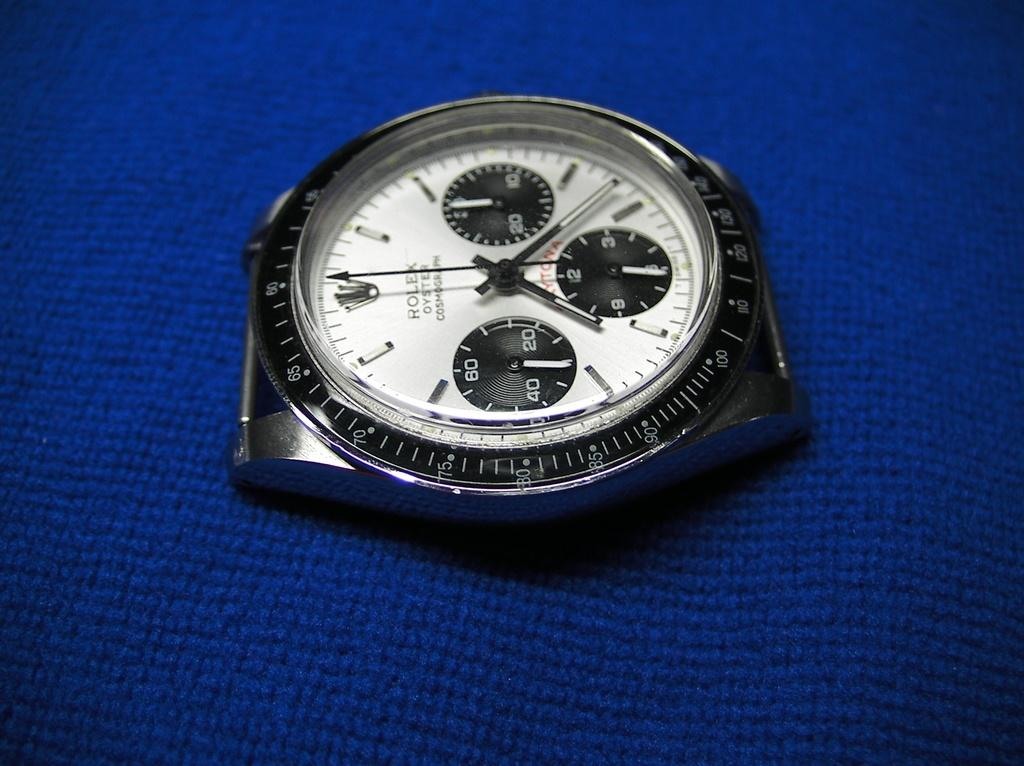<image>
Create a compact narrative representing the image presented. Face of a watch which has the word ROLEX on it. 